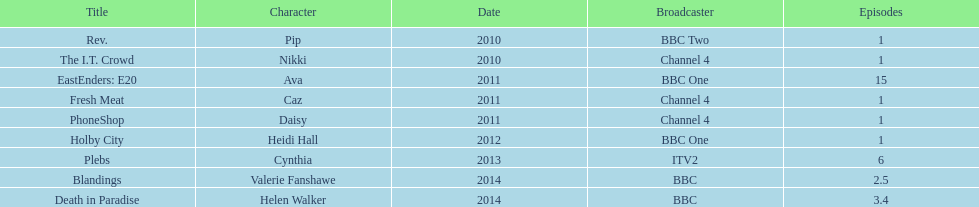Were there more than four episodes that featured cynthia? Yes. 